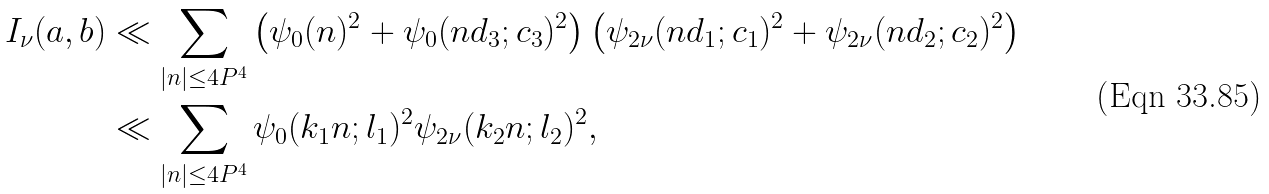<formula> <loc_0><loc_0><loc_500><loc_500>I _ { \nu } ( a , b ) & \ll \sum _ { | n | \leq 4 P ^ { 4 } } \left ( \psi _ { 0 } ( n ) ^ { 2 } + \psi _ { 0 } ( n d _ { 3 } ; c _ { 3 } ) ^ { 2 } \right ) \left ( \psi _ { 2 \nu } ( n d _ { 1 } ; c _ { 1 } ) ^ { 2 } + \psi _ { 2 \nu } ( n d _ { 2 } ; c _ { 2 } ) ^ { 2 } \right ) \\ & \ll \sum _ { | n | \leq 4 P ^ { 4 } } \psi _ { 0 } ( k _ { 1 } n ; l _ { 1 } ) ^ { 2 } \psi _ { 2 \nu } ( k _ { 2 } n ; l _ { 2 } ) ^ { 2 } ,</formula> 